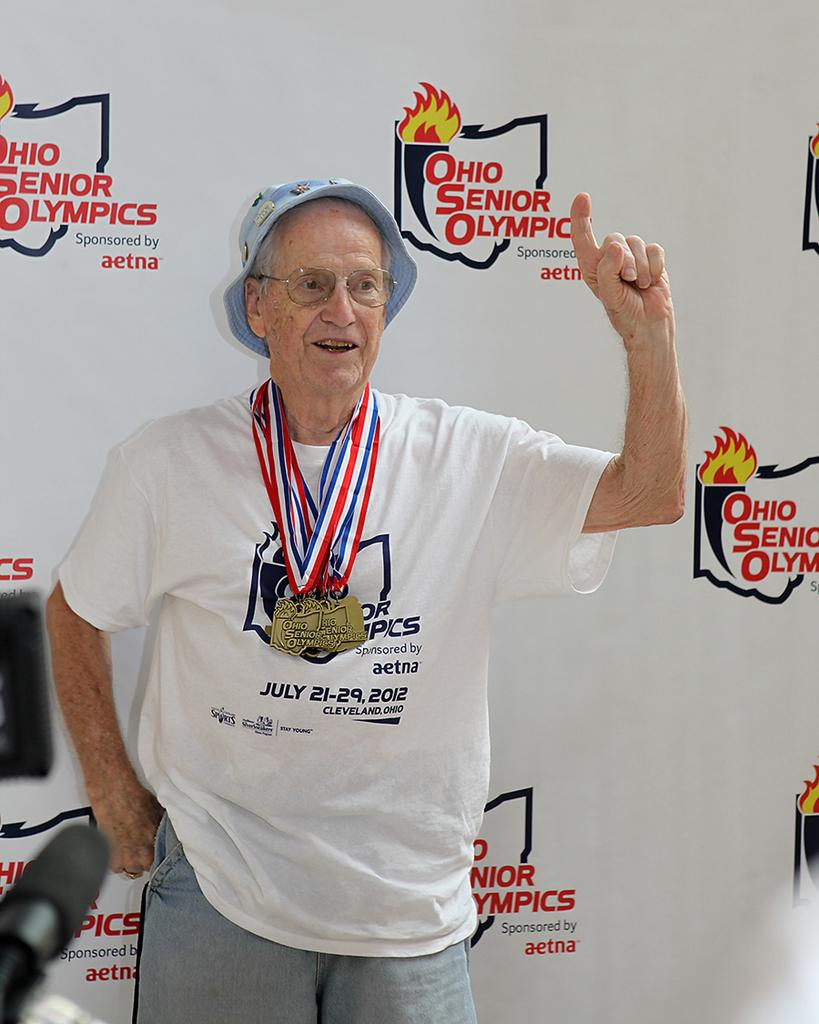<image>
Write a terse but informative summary of the picture. The Ohio Senior Olympics took place on July 21-29 in 2012. 